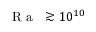Convert formula to latex. <formula><loc_0><loc_0><loc_500><loc_500>{ R a } \gtrsim 1 0 ^ { 1 0 }</formula> 